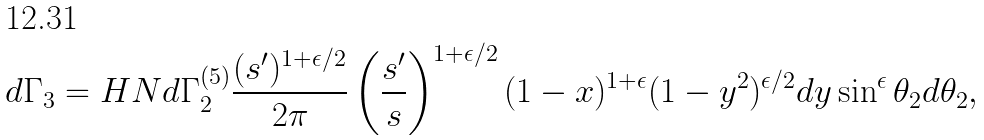Convert formula to latex. <formula><loc_0><loc_0><loc_500><loc_500>d \Gamma _ { 3 } = H N d \Gamma _ { 2 } ^ { ( 5 ) } \frac { ( s ^ { \prime } ) ^ { 1 + \epsilon / 2 } } { 2 \pi } \left ( \frac { s ^ { \prime } } { s } \right ) ^ { 1 + \epsilon / 2 } ( 1 - x ) ^ { 1 + \epsilon } ( 1 - y ^ { 2 } ) ^ { \epsilon / 2 } d y \sin ^ { \epsilon } \theta _ { 2 } d \theta _ { 2 } ,</formula> 